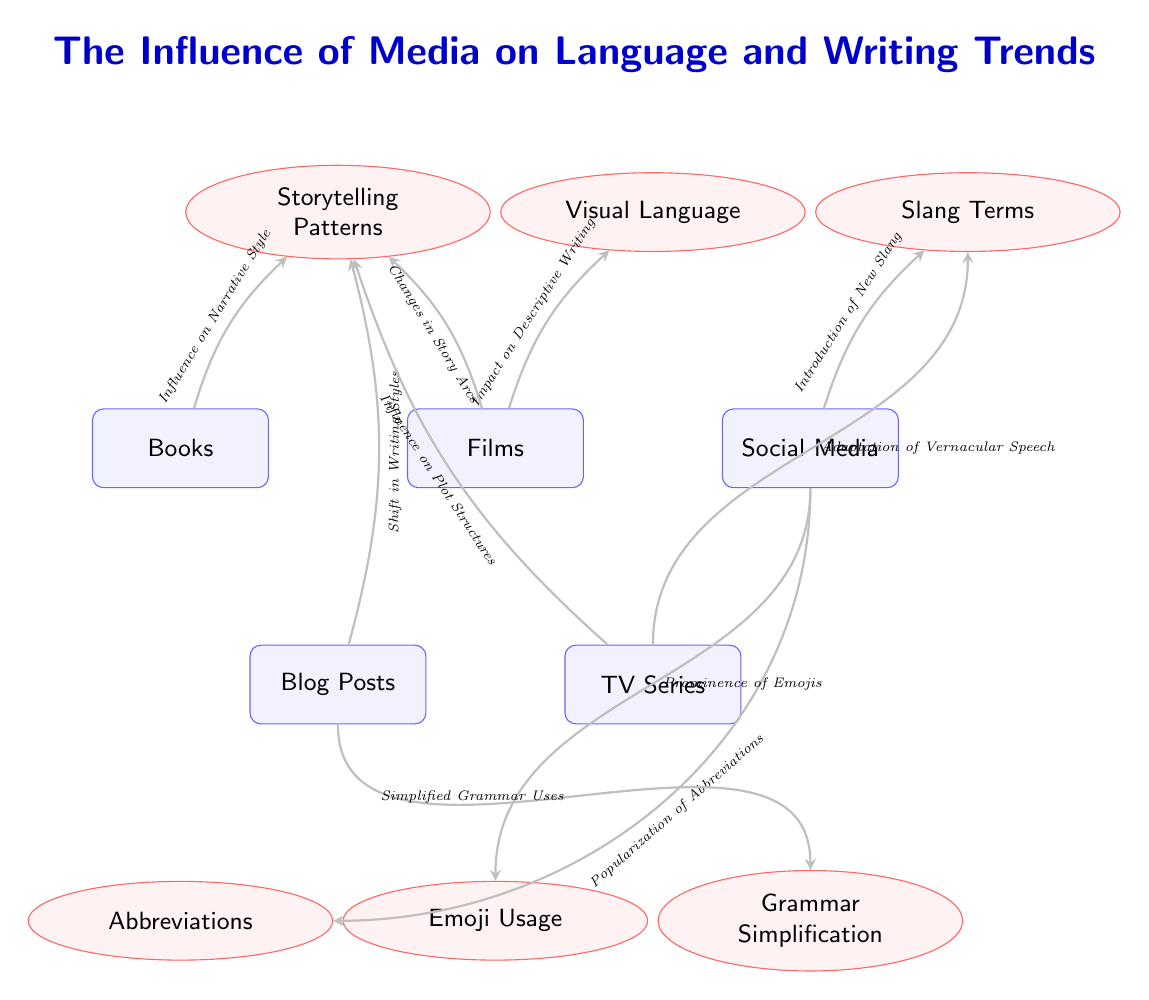What media influenced storytelling patterns? The diagram shows a direct link from the node "Books" to the effect node "Storytelling Patterns," indicating that books have an influence on how stories are told.
Answer: Books Which media is linked to the use of emojis? The arrow in the diagram connects "Social Media" to the effect node "Emoji Usage," showing that social media is where emojis have become prominent.
Answer: Social Media How many nodes represent forms of media in the diagram? Counting the media nodes, we see five nodes labeled as "Books," "Films," "Social Media," "Blog Posts," and "TV Series," which totals to five.
Answer: 5 What effect does films have on narrative style? The diagram does not show a direct connection from "Films" to "Narrative Style." Instead, the link is from "Films" to "Descriptive Writing" which indirectly may affect narrative style through visualization.
Answer: None What is the relationship between social media and abbreviations? The diagram shows a direct connection from the "Social Media" node to the effect node "Abbreviations," indicating that social media contributes to the popularization of abbreviations.
Answer: Popularization of Abbreviations Which form of media affects grammar simplification? The diagram directly connects "Blog Posts" with "Simplified Grammar Uses," indicating that blog posts significantly impact grammar simplification.
Answer: Blog Posts How many relationships (arrows) are shown in the diagram? The diagram displays ten arrows connecting various media and effects, illustrating multiple relationships within the diagram.
Answer: 10 What type of language has been introduced by social media? The effect node "Slang Terms" is connected to the "Social Media," showing social media's influence in introducing new slang to the language.
Answer: Slang Terms Which media appears to have the most influences in the diagram? Analyzing the connections, "Social Media" has three arrows pointing to different effects: "Slang Terms," "Abbreviations," and "Emoji Usage," suggesting it has the most influences.
Answer: Social Media What does "TV Series" primarily influence according to the diagram? The diagram shows that "TV Series" connects with "Slang Terms" and "Storytelling Patterns," indicating its primary influences are on language use and narrative structures.
Answer: Storytelling Patterns 